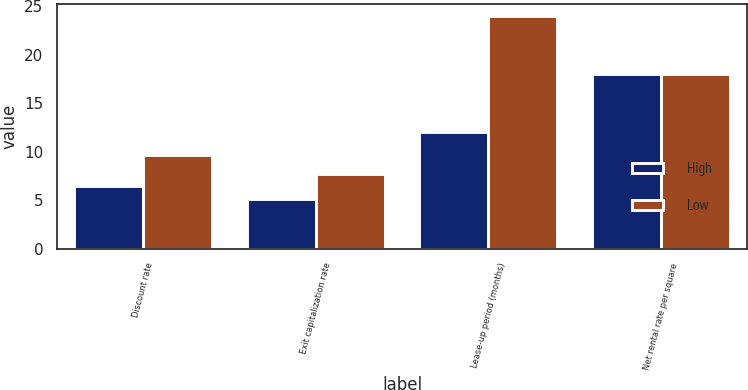Convert chart to OTSL. <chart><loc_0><loc_0><loc_500><loc_500><stacked_bar_chart><ecel><fcel>Discount rate<fcel>Exit capitalization rate<fcel>Lease-up period (months)<fcel>Net rental rate per square<nl><fcel>High<fcel>6.49<fcel>5.09<fcel>12<fcel>18<nl><fcel>Low<fcel>9.67<fcel>7.67<fcel>24<fcel>18<nl></chart> 